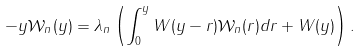<formula> <loc_0><loc_0><loc_500><loc_500>- y \mathcal { W } _ { n } ( y ) = \lambda _ { n } \left ( \int _ { 0 } ^ { y } W ( y - r ) \mathcal { W } _ { n } ( r ) d r + W ( y ) \right ) .</formula> 